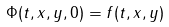<formula> <loc_0><loc_0><loc_500><loc_500>\Phi ( t , x , y , 0 ) = f ( t , x , y )</formula> 